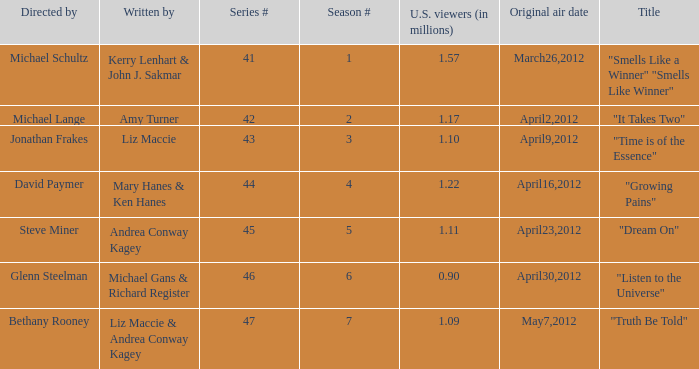What is the title of the episode/s written by Michael Gans & Richard Register? "Listen to the Universe". 